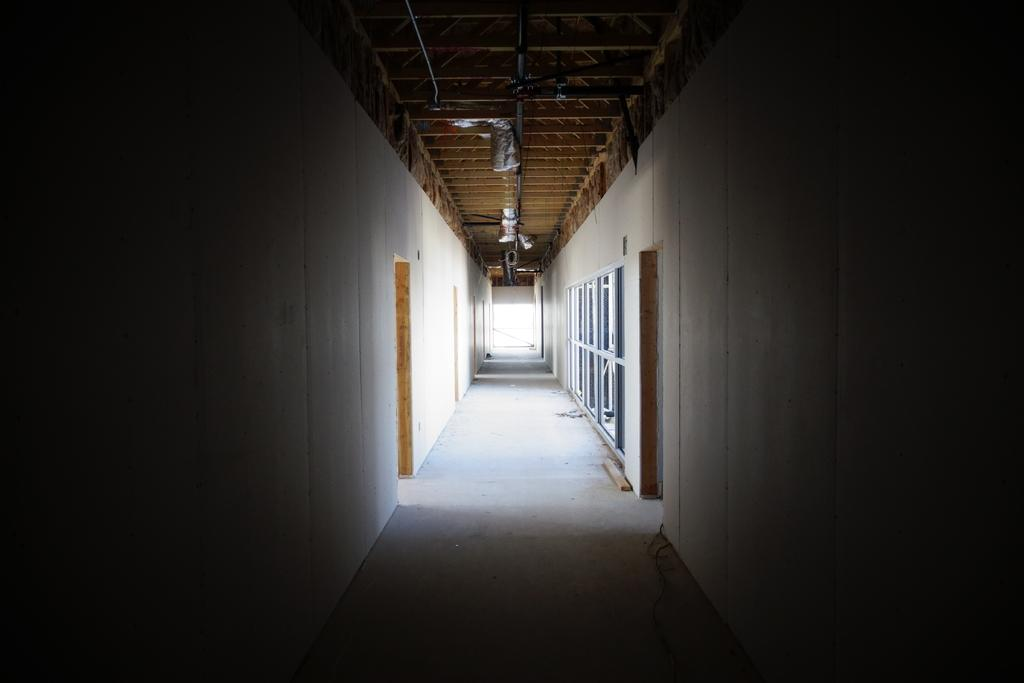What type of pathway is visible in the image? There is a way visible in the image. What structures surround the way? There are walls in the image. Are there any openings in the walls? Yes, there are doors in the image. What additional structure can be seen at the top of the image? There is a shed visible at the top of the image. How many eyes can be seen on the shed in the image? There are no eyes visible on the shed in the image. 